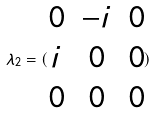<formula> <loc_0><loc_0><loc_500><loc_500>\lambda _ { 2 } = ( \begin{matrix} 0 & - i & 0 \\ i & 0 & 0 \\ 0 & 0 & 0 \end{matrix} )</formula> 